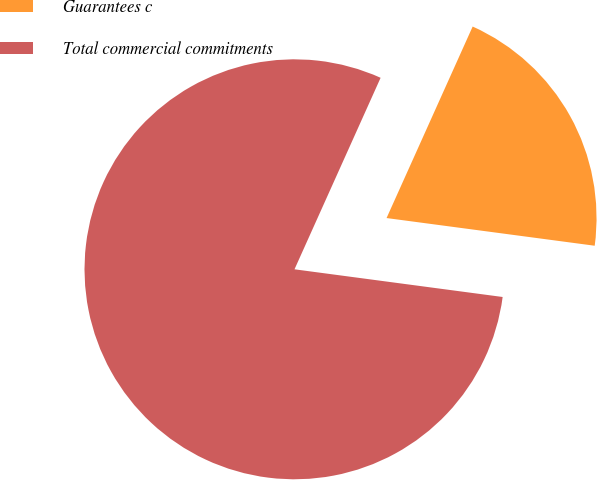Convert chart to OTSL. <chart><loc_0><loc_0><loc_500><loc_500><pie_chart><fcel>Guarantees c<fcel>Total commercial commitments<nl><fcel>20.38%<fcel>79.62%<nl></chart> 